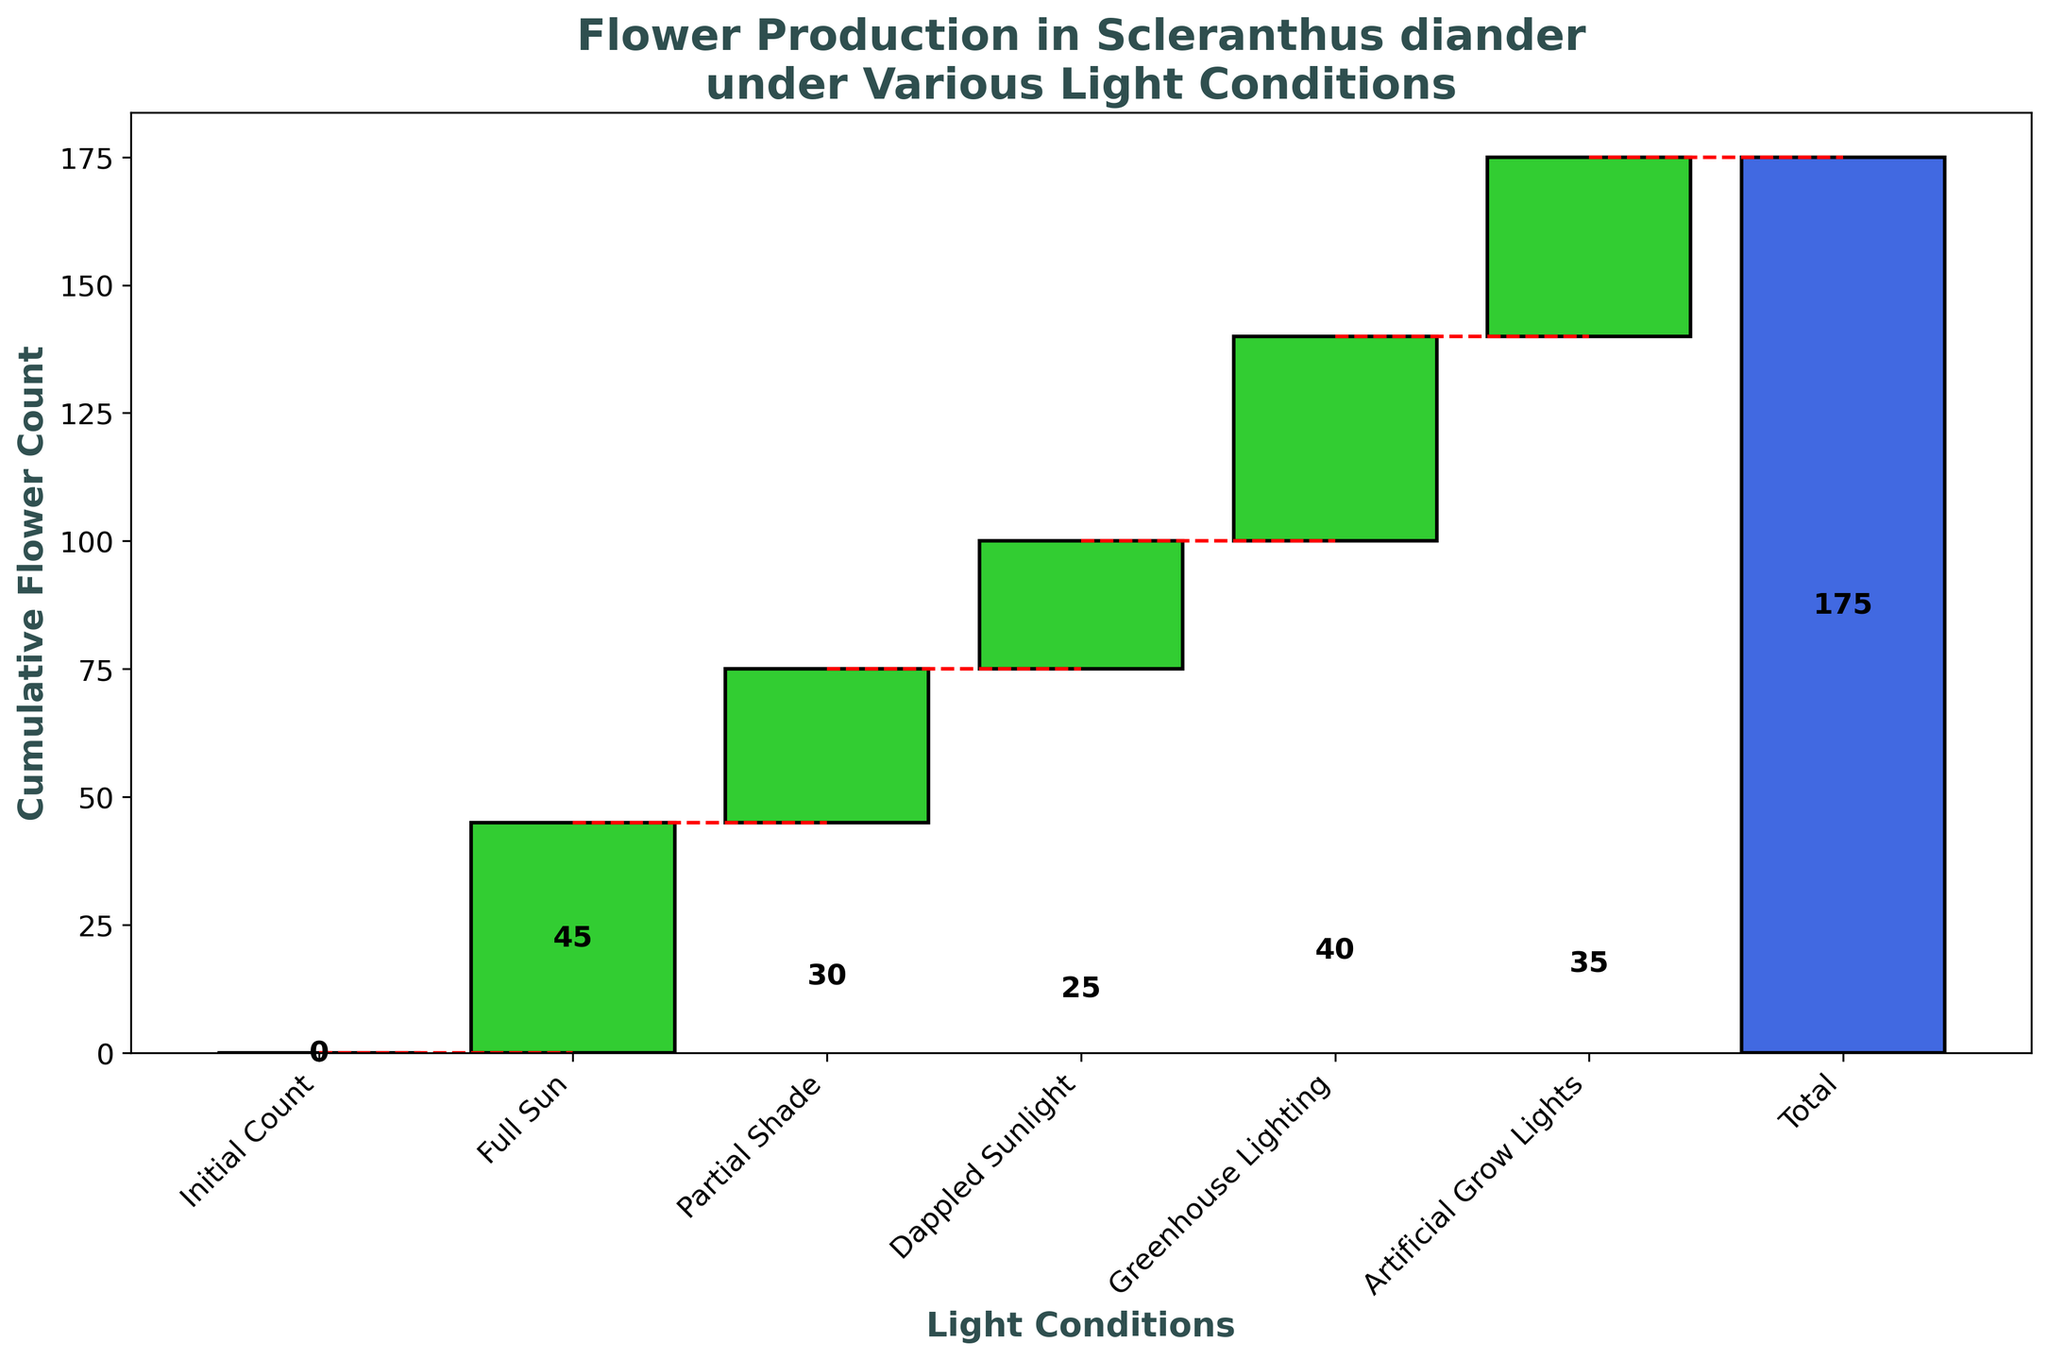What is the title of the figure? The title is located at the top of the figure and summarizes the key focus of the chart. Here, it states: "Flower Production in Scleranthus diander under Various Light Conditions".
Answer: Flower Production in Scleranthus diander under Various Light Conditions How many light conditions are analyzed in the figure? The x-axis of the figure lists the light conditions being analyzed. These conditions are: Initial Count, Full Sun, Partial Shade, Dappled Sunlight, Greenhouse Lighting, and Artificial Grow Lights, making a total of six conditions.
Answer: 6 Which light condition yields the highest increase in flower count? By examining the height of the bars, the largest increase in the flower count is represented by the tallest green bar. Full Sun has the highest increase, shown by the number 45.
Answer: Full Sun What is the cumulative flower count after Full Sun and Partial Shade light conditions? Starting with Full Sun, the increase is 45. Adding the Partial Shade increase of 30, the cumulative total is: 45 + 30 = 75.
Answer: 75 Which two light conditions have the same cumulative flower count increase? Comparing the heights of each bar, Partial Shade (30) and Dappled Sunlight (25) sequentially build up to Greenhouse Lighting's cumulative value. However, there are no two distinct combinations matching in the actual figure based on steps.
Answer: None What is the cumulative flower count after applying all light conditions listed in the figure? The cumulative flower count can be derived by summing the individual increases for each light condition: 45 (Full Sun) + 30 (Partial Shade) + 25 (Dappled Sunlight) + 40 (Greenhouse Lighting) + 35 (Artificial Grow Lights) = 175.
Answer: 175 How much does flower count increase from Artificial Grow Lights compared to Dappled Sunlight? The increase for Dappled Sunlight is 25 and for Artificial Grow Lights is 35. The difference between them is calculated as: 35 - 25 = 10.
Answer: 10 Which condition contributes the least to the cumulative flower count? Among the bars representing each light condition, the shortest bar shows the smallest increase. Dappled Sunlight, with a height of 25, contributes the least.
Answer: Dappled Sunlight What is the total flower count increase contributed by Greenhouse Lighting and Artificial Grow Lights? To find the combined increase of both conditions, add the values represented by their bars: 40 (Greenhouse Lighting) + 35 (Artificial Grow Lights) = 75.
Answer: 75 